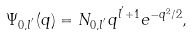Convert formula to latex. <formula><loc_0><loc_0><loc_500><loc_500>\Psi _ { 0 , l ^ { ^ { \prime } } } ( q ) = N _ { 0 , l ^ { ^ { \prime } } } q ^ { l ^ { ^ { \prime } } + 1 } e ^ { - q ^ { 2 } / 2 } ,</formula> 